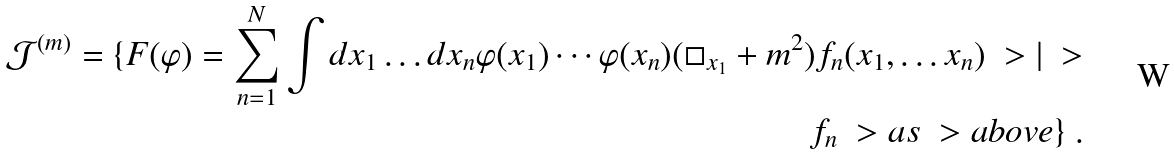Convert formula to latex. <formula><loc_0><loc_0><loc_500><loc_500>\mathcal { J } ^ { ( m ) } = \{ F ( \varphi ) = \sum _ { n = 1 } ^ { N } \int d x _ { 1 } \dots d x _ { n } \varphi ( x _ { 1 } ) \cdots \varphi ( x _ { n } ) ( \square _ { x _ { 1 } } + m ^ { 2 } ) f _ { n } ( x _ { 1 } , \dots x _ { n } ) \ > | \ > \\ f _ { n } \ > a s \ > a b o v e \} \ .</formula> 